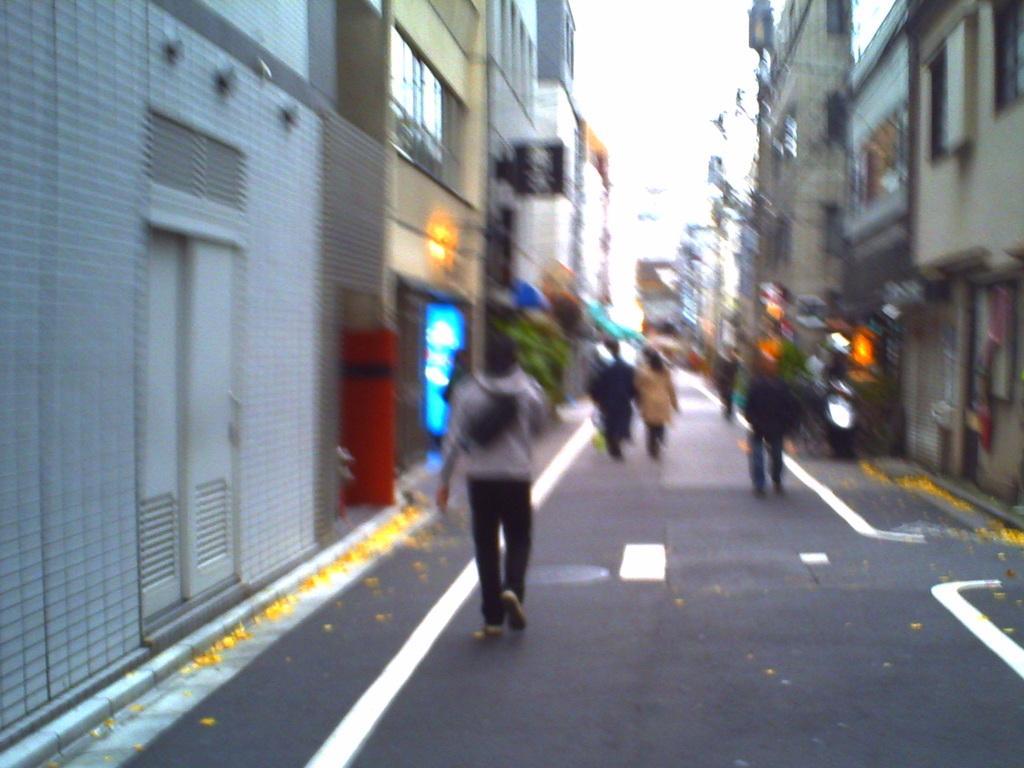Could you give a brief overview of what you see in this image? This image is taken outdoors. At the bottom of the image there is a road. At the top of the image there is the sky. On the left and right sides of the image there are many buildings. In the middle of the image a few people are walking on the road. 